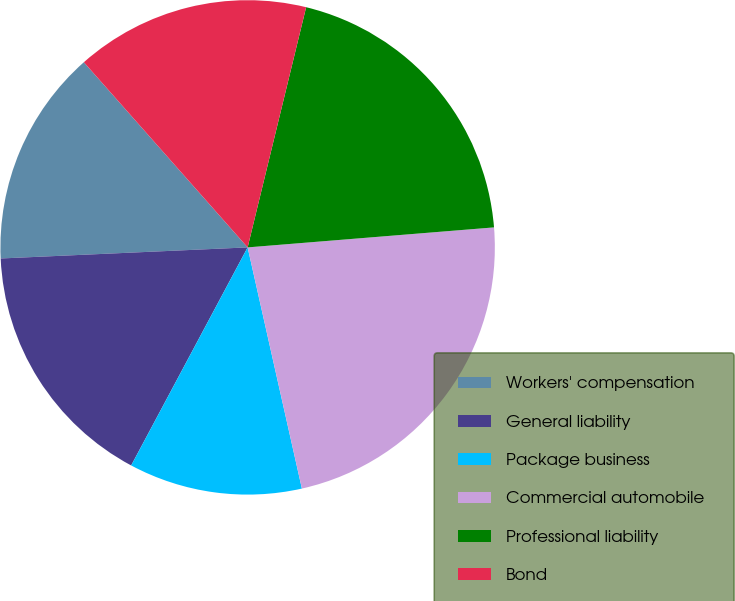Convert chart. <chart><loc_0><loc_0><loc_500><loc_500><pie_chart><fcel>Workers' compensation<fcel>General liability<fcel>Package business<fcel>Commercial automobile<fcel>Professional liability<fcel>Bond<nl><fcel>14.19%<fcel>16.48%<fcel>11.33%<fcel>22.77%<fcel>19.91%<fcel>15.33%<nl></chart> 